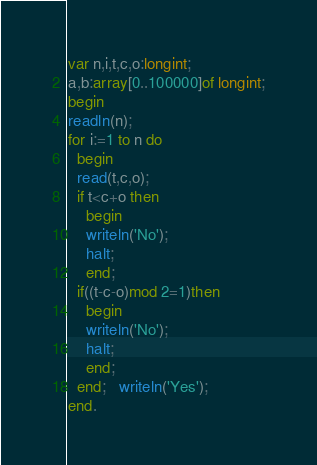Convert code to text. <code><loc_0><loc_0><loc_500><loc_500><_Pascal_>var n,i,t,c,o:longint;
a,b:array[0..100000]of longint;
begin
readln(n);
for i:=1 to n do
  begin
  read(t,c,o);
  if t<c+o then
    begin
    writeln('No');
    halt;
    end;
  if((t-c-o)mod 2=1)then
    begin
    writeln('No');
    halt;
    end;
  end;   writeln('Yes');
end.</code> 